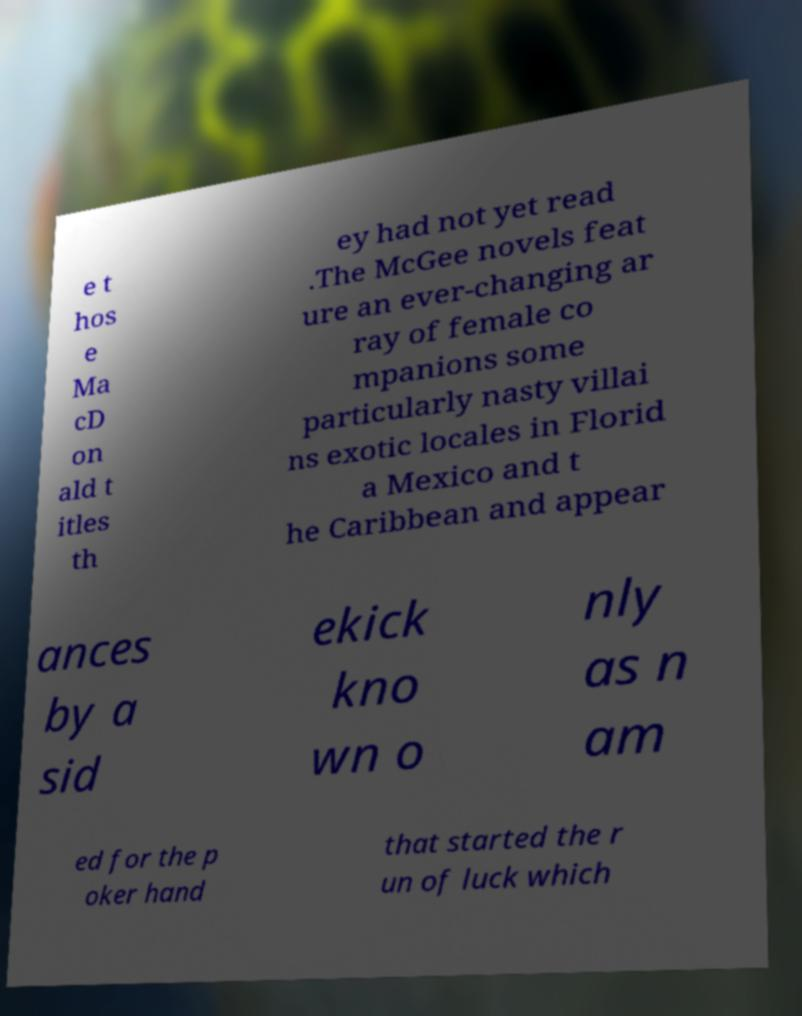Could you extract and type out the text from this image? e t hos e Ma cD on ald t itles th ey had not yet read .The McGee novels feat ure an ever-changing ar ray of female co mpanions some particularly nasty villai ns exotic locales in Florid a Mexico and t he Caribbean and appear ances by a sid ekick kno wn o nly as n am ed for the p oker hand that started the r un of luck which 